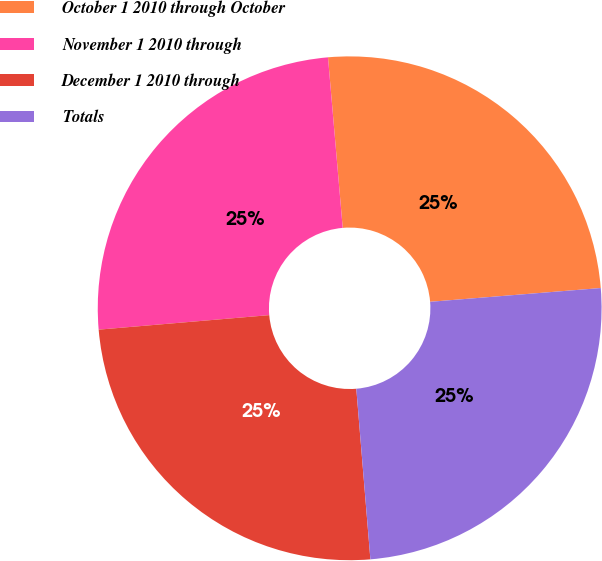Convert chart. <chart><loc_0><loc_0><loc_500><loc_500><pie_chart><fcel>October 1 2010 through October<fcel>November 1 2010 through<fcel>December 1 2010 through<fcel>Totals<nl><fcel>25.09%<fcel>24.98%<fcel>24.96%<fcel>24.97%<nl></chart> 